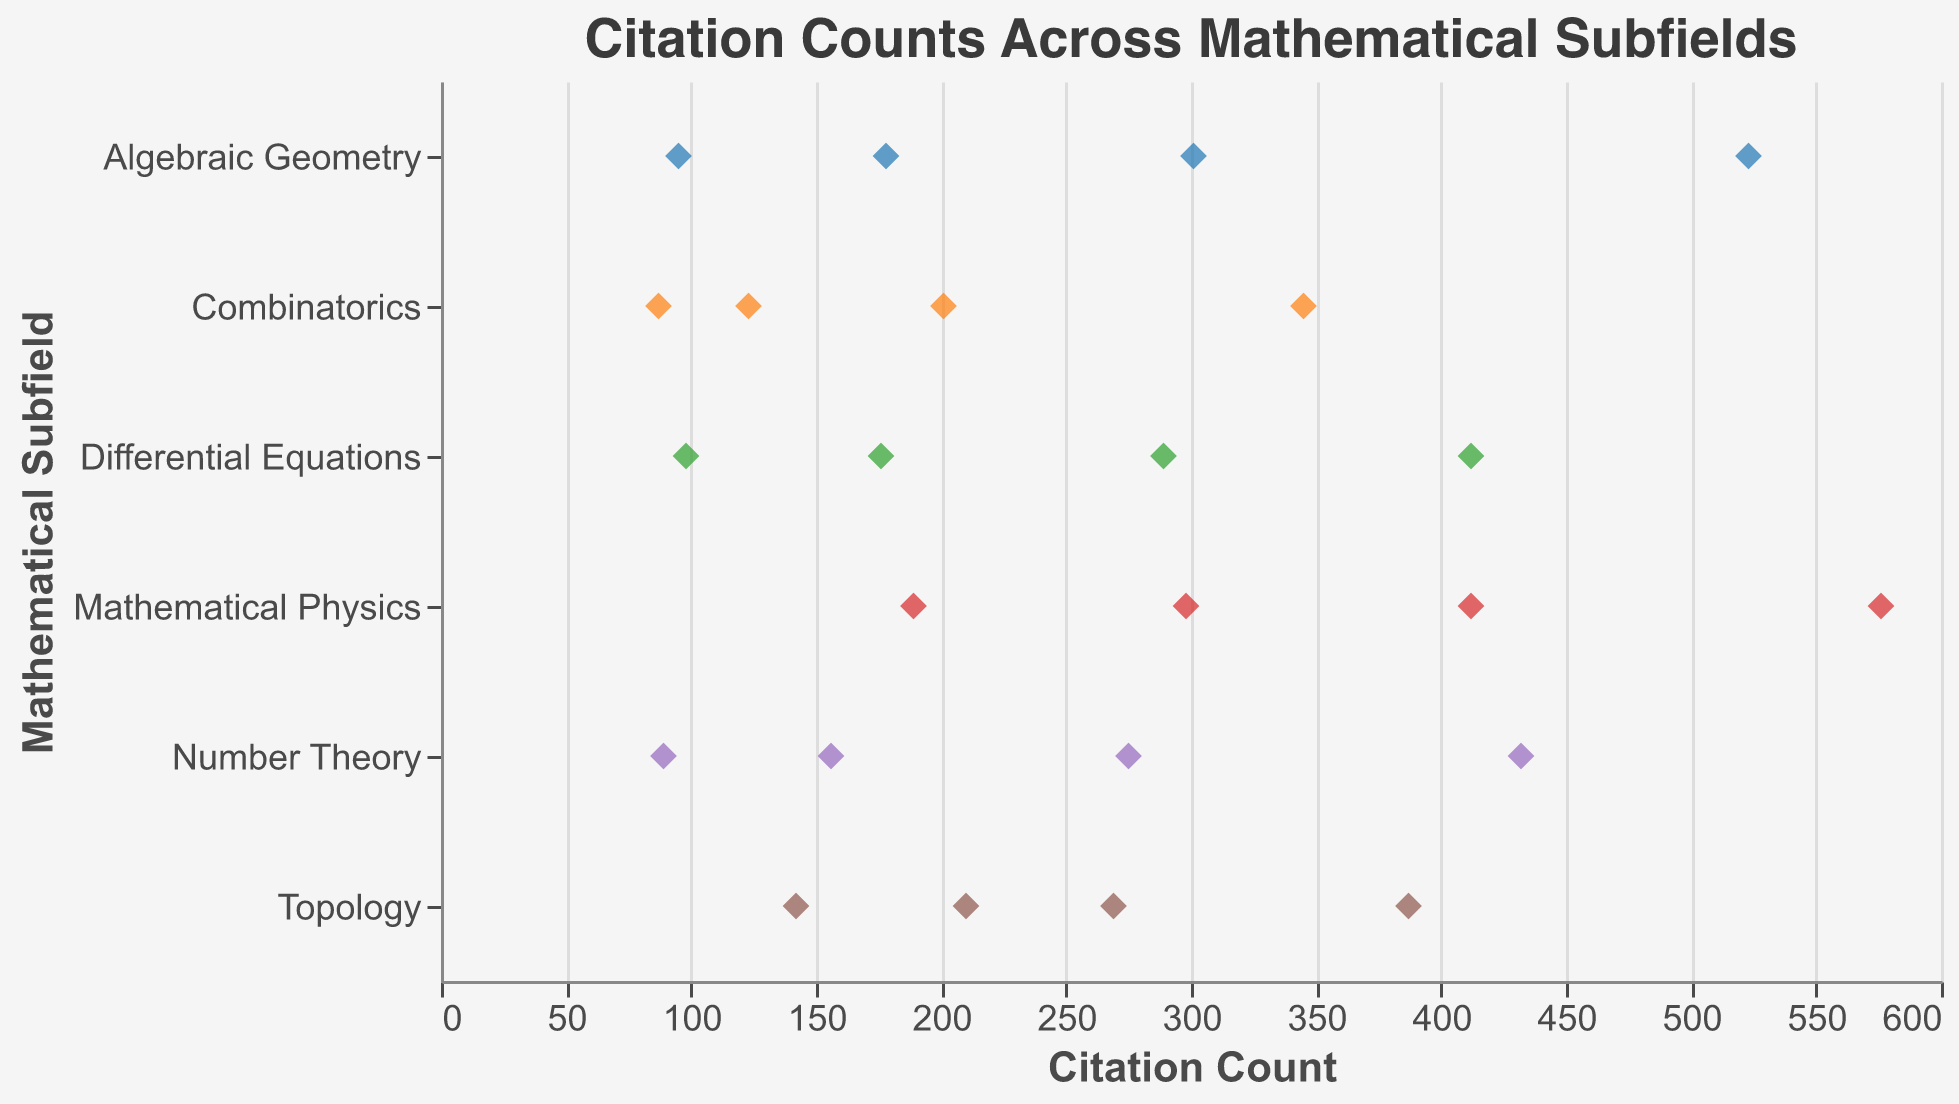1. What is the title of the figure? Look at the top of the figure where the title is usually placed. The title is "Citation Counts Across Mathematical Subfields."
Answer: Citation Counts Across Mathematical Subfields 2. Which subfield has the highest single citation count? Identify the point with the highest value on the x-axis and check the corresponding subfield on the y-axis. Mathematical Physics has the highest citation count of 576.
Answer: Mathematical Physics 3. How many data points are there for the Topology subfield? Count the number of points aligned horizontally with "Topology" on the y-axis. There are 4 data points for Topology.
Answer: 4 4. What is the average citation count for Number Theory? Sum the citation counts for Number Theory (156 + 432 + 89 + 275 = 952) and divide by the number of points (4). The average is 952 / 4 = 238.
Answer: 238 5. Which subfield shows the greatest variation in citation counts? Compare the ranges of citation counts for each subfield. Algebraic Geometry varies from 95 to 523, showing the largest spread.
Answer: Algebraic Geometry 6. Are there more data points with citation counts above or below 300 for Differential Equations? Identify and count the points for Differential Equations on either side of the 300 mark. Above 300: 1 (412); Below 300: 3 (289, 176, 98). There are more below 300.
Answer: below 7. Which subfield has the closest citation counts? Look for subfield citation counts that cluster closely together. Differential Equations has citations 289, 176, 412, and 98 which are relatively close compared to other subfields.
Answer: Differential Equations 8. Which subfield has the highest average citation count? Calculate averages for each subfield. For Mathematical Physics: (412 + 189 + 298 + 576) / 4 = 369. Mathematical Physics has the highest average.
Answer: Mathematical Physics 9. Which subfield has the least variation in citation counts? Compare the spread of citation counts for each subfield. Combinatorics ranges from 87 to 345, showing the smallest variation.
Answer: Combinatorics 10. What is the median citation count for Algebraic Geometry? Organize the citation counts for Algebraic Geometry (95, 178, 301, 523) and find the median. For an even number of points, take the average of the middle two: (178 + 301) / 2 = 239.5.
Answer: 239.5 